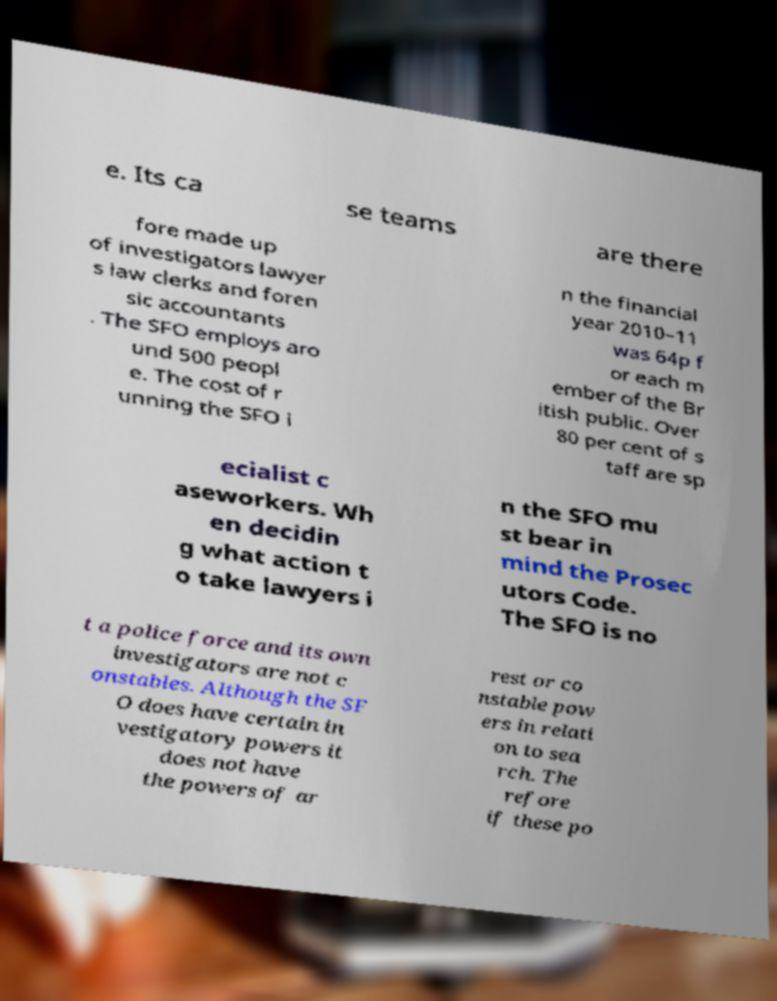For documentation purposes, I need the text within this image transcribed. Could you provide that? e. Its ca se teams are there fore made up of investigators lawyer s law clerks and foren sic accountants . The SFO employs aro und 500 peopl e. The cost of r unning the SFO i n the financial year 2010–11 was 64p f or each m ember of the Br itish public. Over 80 per cent of s taff are sp ecialist c aseworkers. Wh en decidin g what action t o take lawyers i n the SFO mu st bear in mind the Prosec utors Code. The SFO is no t a police force and its own investigators are not c onstables. Although the SF O does have certain in vestigatory powers it does not have the powers of ar rest or co nstable pow ers in relati on to sea rch. The refore if these po 